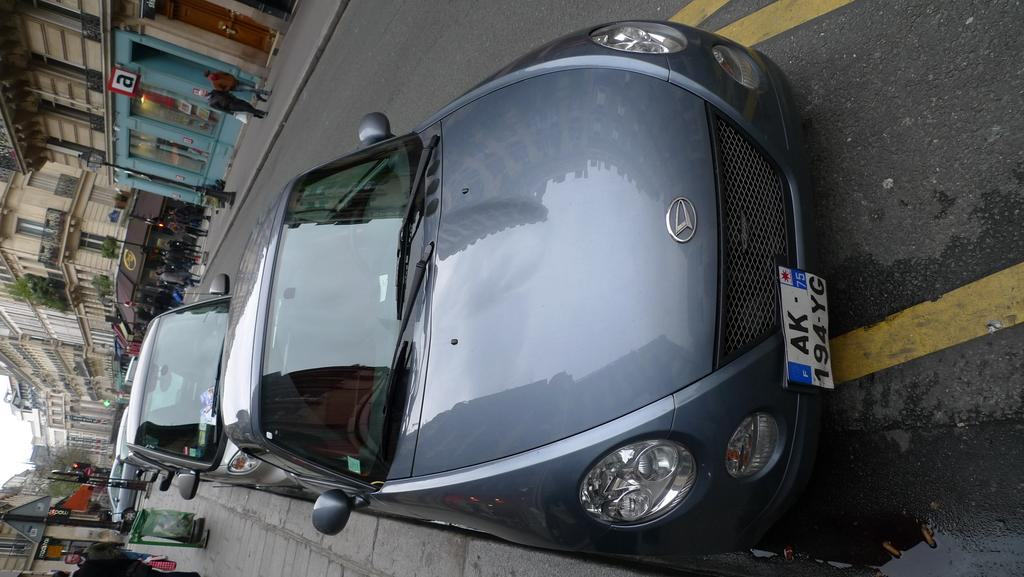<image>
Provide a brief description of the given image. A silver car with the license plate number AK-194-YG is parked along the street. 